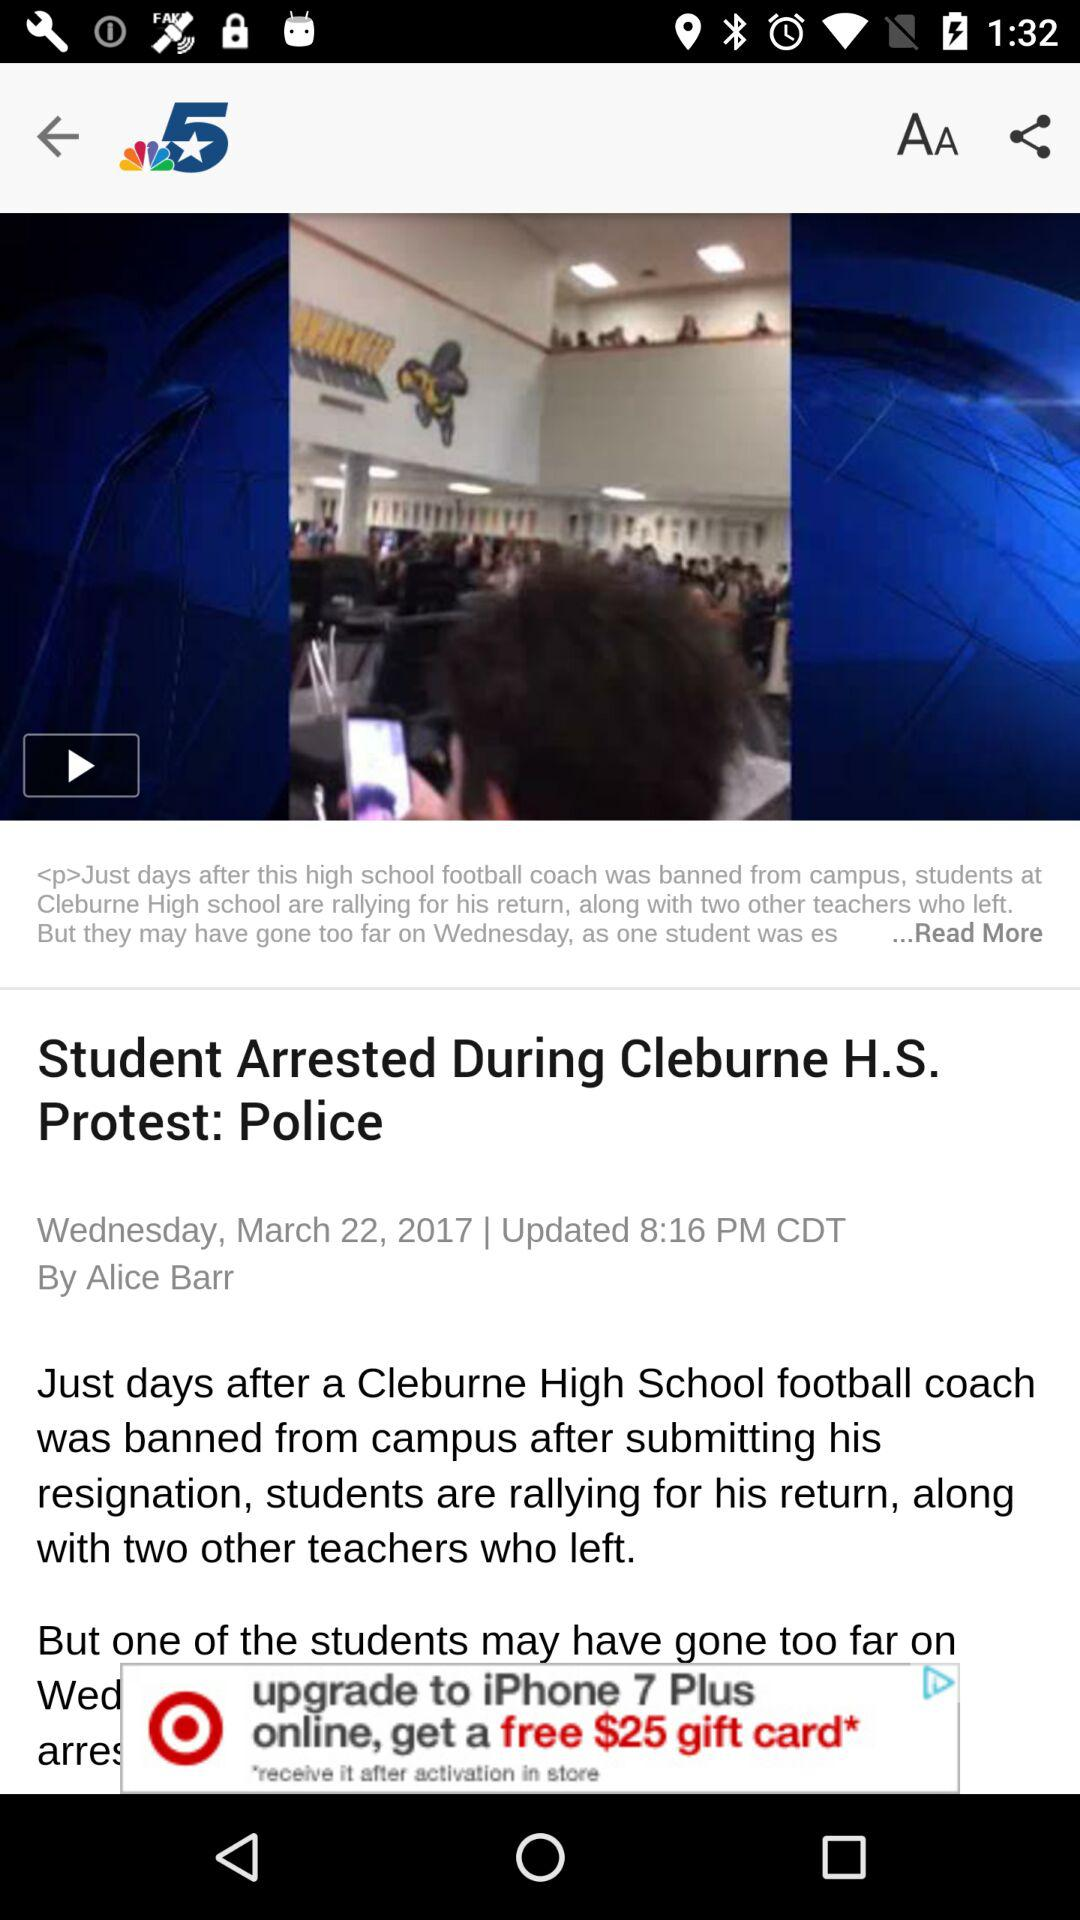The news is written by which writer? The news is written by "Alice Barr". 